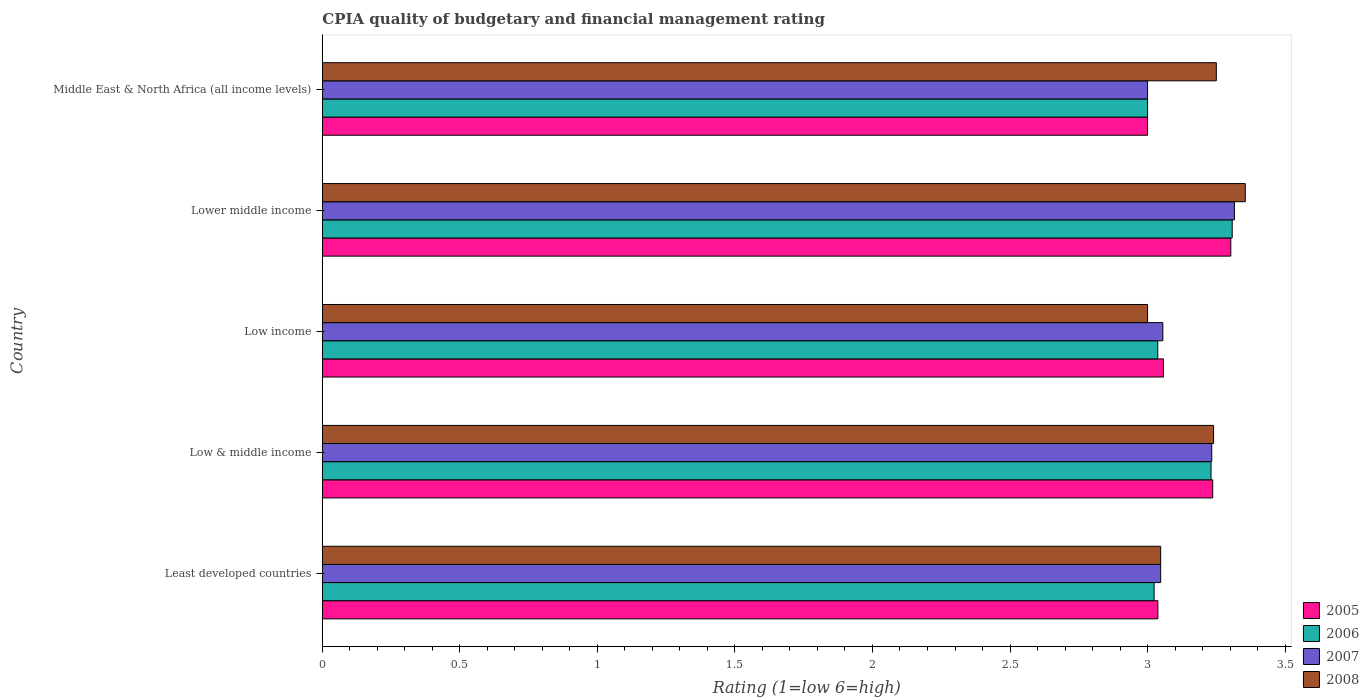How many different coloured bars are there?
Provide a succinct answer. 4. Are the number of bars per tick equal to the number of legend labels?
Make the answer very short. Yes. How many bars are there on the 3rd tick from the bottom?
Offer a terse response. 4. What is the label of the 5th group of bars from the top?
Offer a terse response. Least developed countries. In how many cases, is the number of bars for a given country not equal to the number of legend labels?
Offer a terse response. 0. What is the CPIA rating in 2006 in Low income?
Offer a very short reply. 3.04. Across all countries, what is the maximum CPIA rating in 2006?
Ensure brevity in your answer.  3.31. In which country was the CPIA rating in 2007 maximum?
Provide a succinct answer. Lower middle income. In which country was the CPIA rating in 2005 minimum?
Your answer should be compact. Middle East & North Africa (all income levels). What is the total CPIA rating in 2005 in the graph?
Ensure brevity in your answer.  15.63. What is the difference between the CPIA rating in 2005 in Low & middle income and that in Lower middle income?
Provide a succinct answer. -0.07. What is the difference between the CPIA rating in 2005 in Middle East & North Africa (all income levels) and the CPIA rating in 2007 in Low & middle income?
Give a very brief answer. -0.23. What is the average CPIA rating in 2008 per country?
Provide a short and direct response. 3.18. What is the difference between the CPIA rating in 2006 and CPIA rating in 2008 in Low income?
Make the answer very short. 0.04. What is the ratio of the CPIA rating in 2006 in Lower middle income to that in Middle East & North Africa (all income levels)?
Your response must be concise. 1.1. Is the CPIA rating in 2006 in Least developed countries less than that in Low income?
Your answer should be compact. Yes. Is the difference between the CPIA rating in 2006 in Lower middle income and Middle East & North Africa (all income levels) greater than the difference between the CPIA rating in 2008 in Lower middle income and Middle East & North Africa (all income levels)?
Your response must be concise. Yes. What is the difference between the highest and the second highest CPIA rating in 2006?
Offer a very short reply. 0.08. What is the difference between the highest and the lowest CPIA rating in 2007?
Your answer should be compact. 0.32. In how many countries, is the CPIA rating in 2007 greater than the average CPIA rating in 2007 taken over all countries?
Give a very brief answer. 2. Is it the case that in every country, the sum of the CPIA rating in 2007 and CPIA rating in 2006 is greater than the sum of CPIA rating in 2008 and CPIA rating in 2005?
Your response must be concise. No. How many bars are there?
Make the answer very short. 20. Does the graph contain any zero values?
Your response must be concise. No. Does the graph contain grids?
Your answer should be very brief. No. How many legend labels are there?
Ensure brevity in your answer.  4. How are the legend labels stacked?
Provide a succinct answer. Vertical. What is the title of the graph?
Give a very brief answer. CPIA quality of budgetary and financial management rating. Does "1990" appear as one of the legend labels in the graph?
Ensure brevity in your answer.  No. What is the Rating (1=low 6=high) in 2005 in Least developed countries?
Make the answer very short. 3.04. What is the Rating (1=low 6=high) in 2006 in Least developed countries?
Your answer should be very brief. 3.02. What is the Rating (1=low 6=high) in 2007 in Least developed countries?
Your answer should be very brief. 3.05. What is the Rating (1=low 6=high) in 2008 in Least developed countries?
Keep it short and to the point. 3.05. What is the Rating (1=low 6=high) of 2005 in Low & middle income?
Keep it short and to the point. 3.24. What is the Rating (1=low 6=high) of 2006 in Low & middle income?
Provide a short and direct response. 3.23. What is the Rating (1=low 6=high) of 2007 in Low & middle income?
Provide a short and direct response. 3.23. What is the Rating (1=low 6=high) in 2008 in Low & middle income?
Offer a very short reply. 3.24. What is the Rating (1=low 6=high) in 2005 in Low income?
Ensure brevity in your answer.  3.06. What is the Rating (1=low 6=high) in 2006 in Low income?
Provide a succinct answer. 3.04. What is the Rating (1=low 6=high) of 2007 in Low income?
Provide a succinct answer. 3.06. What is the Rating (1=low 6=high) of 2005 in Lower middle income?
Provide a short and direct response. 3.3. What is the Rating (1=low 6=high) in 2006 in Lower middle income?
Ensure brevity in your answer.  3.31. What is the Rating (1=low 6=high) in 2007 in Lower middle income?
Give a very brief answer. 3.32. What is the Rating (1=low 6=high) of 2008 in Lower middle income?
Provide a succinct answer. 3.36. What is the Rating (1=low 6=high) of 2008 in Middle East & North Africa (all income levels)?
Provide a short and direct response. 3.25. Across all countries, what is the maximum Rating (1=low 6=high) of 2005?
Make the answer very short. 3.3. Across all countries, what is the maximum Rating (1=low 6=high) of 2006?
Offer a very short reply. 3.31. Across all countries, what is the maximum Rating (1=low 6=high) of 2007?
Your response must be concise. 3.32. Across all countries, what is the maximum Rating (1=low 6=high) in 2008?
Your answer should be very brief. 3.36. Across all countries, what is the minimum Rating (1=low 6=high) of 2007?
Make the answer very short. 3. Across all countries, what is the minimum Rating (1=low 6=high) of 2008?
Your answer should be very brief. 3. What is the total Rating (1=low 6=high) of 2005 in the graph?
Provide a short and direct response. 15.63. What is the total Rating (1=low 6=high) in 2006 in the graph?
Provide a succinct answer. 15.6. What is the total Rating (1=low 6=high) in 2007 in the graph?
Your answer should be very brief. 15.65. What is the total Rating (1=low 6=high) in 2008 in the graph?
Offer a very short reply. 15.89. What is the difference between the Rating (1=low 6=high) in 2005 in Least developed countries and that in Low & middle income?
Provide a short and direct response. -0.2. What is the difference between the Rating (1=low 6=high) of 2006 in Least developed countries and that in Low & middle income?
Your answer should be compact. -0.21. What is the difference between the Rating (1=low 6=high) in 2007 in Least developed countries and that in Low & middle income?
Give a very brief answer. -0.19. What is the difference between the Rating (1=low 6=high) of 2008 in Least developed countries and that in Low & middle income?
Your answer should be compact. -0.19. What is the difference between the Rating (1=low 6=high) in 2005 in Least developed countries and that in Low income?
Ensure brevity in your answer.  -0.02. What is the difference between the Rating (1=low 6=high) of 2006 in Least developed countries and that in Low income?
Your answer should be compact. -0.01. What is the difference between the Rating (1=low 6=high) of 2007 in Least developed countries and that in Low income?
Ensure brevity in your answer.  -0.01. What is the difference between the Rating (1=low 6=high) of 2008 in Least developed countries and that in Low income?
Your answer should be very brief. 0.05. What is the difference between the Rating (1=low 6=high) of 2005 in Least developed countries and that in Lower middle income?
Your answer should be very brief. -0.27. What is the difference between the Rating (1=low 6=high) of 2006 in Least developed countries and that in Lower middle income?
Your answer should be compact. -0.28. What is the difference between the Rating (1=low 6=high) in 2007 in Least developed countries and that in Lower middle income?
Give a very brief answer. -0.27. What is the difference between the Rating (1=low 6=high) in 2008 in Least developed countries and that in Lower middle income?
Your response must be concise. -0.31. What is the difference between the Rating (1=low 6=high) of 2005 in Least developed countries and that in Middle East & North Africa (all income levels)?
Make the answer very short. 0.04. What is the difference between the Rating (1=low 6=high) in 2006 in Least developed countries and that in Middle East & North Africa (all income levels)?
Give a very brief answer. 0.02. What is the difference between the Rating (1=low 6=high) in 2007 in Least developed countries and that in Middle East & North Africa (all income levels)?
Make the answer very short. 0.05. What is the difference between the Rating (1=low 6=high) of 2008 in Least developed countries and that in Middle East & North Africa (all income levels)?
Your answer should be very brief. -0.2. What is the difference between the Rating (1=low 6=high) of 2005 in Low & middle income and that in Low income?
Give a very brief answer. 0.18. What is the difference between the Rating (1=low 6=high) in 2006 in Low & middle income and that in Low income?
Ensure brevity in your answer.  0.19. What is the difference between the Rating (1=low 6=high) in 2007 in Low & middle income and that in Low income?
Your answer should be compact. 0.18. What is the difference between the Rating (1=low 6=high) in 2008 in Low & middle income and that in Low income?
Provide a succinct answer. 0.24. What is the difference between the Rating (1=low 6=high) of 2005 in Low & middle income and that in Lower middle income?
Make the answer very short. -0.07. What is the difference between the Rating (1=low 6=high) of 2006 in Low & middle income and that in Lower middle income?
Provide a succinct answer. -0.08. What is the difference between the Rating (1=low 6=high) in 2007 in Low & middle income and that in Lower middle income?
Ensure brevity in your answer.  -0.08. What is the difference between the Rating (1=low 6=high) in 2008 in Low & middle income and that in Lower middle income?
Offer a terse response. -0.12. What is the difference between the Rating (1=low 6=high) in 2005 in Low & middle income and that in Middle East & North Africa (all income levels)?
Ensure brevity in your answer.  0.24. What is the difference between the Rating (1=low 6=high) in 2006 in Low & middle income and that in Middle East & North Africa (all income levels)?
Provide a succinct answer. 0.23. What is the difference between the Rating (1=low 6=high) of 2007 in Low & middle income and that in Middle East & North Africa (all income levels)?
Keep it short and to the point. 0.23. What is the difference between the Rating (1=low 6=high) in 2008 in Low & middle income and that in Middle East & North Africa (all income levels)?
Your answer should be very brief. -0.01. What is the difference between the Rating (1=low 6=high) of 2005 in Low income and that in Lower middle income?
Give a very brief answer. -0.24. What is the difference between the Rating (1=low 6=high) in 2006 in Low income and that in Lower middle income?
Keep it short and to the point. -0.27. What is the difference between the Rating (1=low 6=high) of 2007 in Low income and that in Lower middle income?
Make the answer very short. -0.26. What is the difference between the Rating (1=low 6=high) in 2008 in Low income and that in Lower middle income?
Your answer should be compact. -0.36. What is the difference between the Rating (1=low 6=high) in 2005 in Low income and that in Middle East & North Africa (all income levels)?
Your response must be concise. 0.06. What is the difference between the Rating (1=low 6=high) of 2006 in Low income and that in Middle East & North Africa (all income levels)?
Keep it short and to the point. 0.04. What is the difference between the Rating (1=low 6=high) in 2007 in Low income and that in Middle East & North Africa (all income levels)?
Give a very brief answer. 0.06. What is the difference between the Rating (1=low 6=high) in 2005 in Lower middle income and that in Middle East & North Africa (all income levels)?
Offer a terse response. 0.3. What is the difference between the Rating (1=low 6=high) of 2006 in Lower middle income and that in Middle East & North Africa (all income levels)?
Keep it short and to the point. 0.31. What is the difference between the Rating (1=low 6=high) in 2007 in Lower middle income and that in Middle East & North Africa (all income levels)?
Your answer should be very brief. 0.32. What is the difference between the Rating (1=low 6=high) of 2008 in Lower middle income and that in Middle East & North Africa (all income levels)?
Your answer should be compact. 0.11. What is the difference between the Rating (1=low 6=high) in 2005 in Least developed countries and the Rating (1=low 6=high) in 2006 in Low & middle income?
Provide a short and direct response. -0.19. What is the difference between the Rating (1=low 6=high) in 2005 in Least developed countries and the Rating (1=low 6=high) in 2007 in Low & middle income?
Provide a succinct answer. -0.2. What is the difference between the Rating (1=low 6=high) in 2005 in Least developed countries and the Rating (1=low 6=high) in 2008 in Low & middle income?
Provide a succinct answer. -0.2. What is the difference between the Rating (1=low 6=high) of 2006 in Least developed countries and the Rating (1=low 6=high) of 2007 in Low & middle income?
Offer a very short reply. -0.21. What is the difference between the Rating (1=low 6=high) of 2006 in Least developed countries and the Rating (1=low 6=high) of 2008 in Low & middle income?
Make the answer very short. -0.22. What is the difference between the Rating (1=low 6=high) of 2007 in Least developed countries and the Rating (1=low 6=high) of 2008 in Low & middle income?
Ensure brevity in your answer.  -0.19. What is the difference between the Rating (1=low 6=high) of 2005 in Least developed countries and the Rating (1=low 6=high) of 2006 in Low income?
Your response must be concise. 0. What is the difference between the Rating (1=low 6=high) in 2005 in Least developed countries and the Rating (1=low 6=high) in 2007 in Low income?
Offer a terse response. -0.02. What is the difference between the Rating (1=low 6=high) in 2005 in Least developed countries and the Rating (1=low 6=high) in 2008 in Low income?
Give a very brief answer. 0.04. What is the difference between the Rating (1=low 6=high) in 2006 in Least developed countries and the Rating (1=low 6=high) in 2007 in Low income?
Your answer should be very brief. -0.03. What is the difference between the Rating (1=low 6=high) in 2006 in Least developed countries and the Rating (1=low 6=high) in 2008 in Low income?
Provide a short and direct response. 0.02. What is the difference between the Rating (1=low 6=high) in 2007 in Least developed countries and the Rating (1=low 6=high) in 2008 in Low income?
Give a very brief answer. 0.05. What is the difference between the Rating (1=low 6=high) of 2005 in Least developed countries and the Rating (1=low 6=high) of 2006 in Lower middle income?
Your response must be concise. -0.27. What is the difference between the Rating (1=low 6=high) of 2005 in Least developed countries and the Rating (1=low 6=high) of 2007 in Lower middle income?
Offer a terse response. -0.28. What is the difference between the Rating (1=low 6=high) of 2005 in Least developed countries and the Rating (1=low 6=high) of 2008 in Lower middle income?
Keep it short and to the point. -0.32. What is the difference between the Rating (1=low 6=high) of 2006 in Least developed countries and the Rating (1=low 6=high) of 2007 in Lower middle income?
Give a very brief answer. -0.29. What is the difference between the Rating (1=low 6=high) in 2006 in Least developed countries and the Rating (1=low 6=high) in 2008 in Lower middle income?
Your response must be concise. -0.33. What is the difference between the Rating (1=low 6=high) of 2007 in Least developed countries and the Rating (1=low 6=high) of 2008 in Lower middle income?
Your answer should be very brief. -0.31. What is the difference between the Rating (1=low 6=high) of 2005 in Least developed countries and the Rating (1=low 6=high) of 2006 in Middle East & North Africa (all income levels)?
Keep it short and to the point. 0.04. What is the difference between the Rating (1=low 6=high) in 2005 in Least developed countries and the Rating (1=low 6=high) in 2007 in Middle East & North Africa (all income levels)?
Your response must be concise. 0.04. What is the difference between the Rating (1=low 6=high) of 2005 in Least developed countries and the Rating (1=low 6=high) of 2008 in Middle East & North Africa (all income levels)?
Your response must be concise. -0.21. What is the difference between the Rating (1=low 6=high) of 2006 in Least developed countries and the Rating (1=low 6=high) of 2007 in Middle East & North Africa (all income levels)?
Ensure brevity in your answer.  0.02. What is the difference between the Rating (1=low 6=high) of 2006 in Least developed countries and the Rating (1=low 6=high) of 2008 in Middle East & North Africa (all income levels)?
Your answer should be very brief. -0.23. What is the difference between the Rating (1=low 6=high) of 2007 in Least developed countries and the Rating (1=low 6=high) of 2008 in Middle East & North Africa (all income levels)?
Offer a terse response. -0.2. What is the difference between the Rating (1=low 6=high) of 2005 in Low & middle income and the Rating (1=low 6=high) of 2006 in Low income?
Keep it short and to the point. 0.2. What is the difference between the Rating (1=low 6=high) of 2005 in Low & middle income and the Rating (1=low 6=high) of 2007 in Low income?
Keep it short and to the point. 0.18. What is the difference between the Rating (1=low 6=high) of 2005 in Low & middle income and the Rating (1=low 6=high) of 2008 in Low income?
Provide a succinct answer. 0.24. What is the difference between the Rating (1=low 6=high) in 2006 in Low & middle income and the Rating (1=low 6=high) in 2007 in Low income?
Offer a very short reply. 0.18. What is the difference between the Rating (1=low 6=high) in 2006 in Low & middle income and the Rating (1=low 6=high) in 2008 in Low income?
Give a very brief answer. 0.23. What is the difference between the Rating (1=low 6=high) of 2007 in Low & middle income and the Rating (1=low 6=high) of 2008 in Low income?
Give a very brief answer. 0.23. What is the difference between the Rating (1=low 6=high) of 2005 in Low & middle income and the Rating (1=low 6=high) of 2006 in Lower middle income?
Your answer should be very brief. -0.07. What is the difference between the Rating (1=low 6=high) in 2005 in Low & middle income and the Rating (1=low 6=high) in 2007 in Lower middle income?
Offer a terse response. -0.08. What is the difference between the Rating (1=low 6=high) of 2005 in Low & middle income and the Rating (1=low 6=high) of 2008 in Lower middle income?
Provide a succinct answer. -0.12. What is the difference between the Rating (1=low 6=high) in 2006 in Low & middle income and the Rating (1=low 6=high) in 2007 in Lower middle income?
Your answer should be very brief. -0.09. What is the difference between the Rating (1=low 6=high) in 2006 in Low & middle income and the Rating (1=low 6=high) in 2008 in Lower middle income?
Your answer should be compact. -0.12. What is the difference between the Rating (1=low 6=high) in 2007 in Low & middle income and the Rating (1=low 6=high) in 2008 in Lower middle income?
Provide a short and direct response. -0.12. What is the difference between the Rating (1=low 6=high) in 2005 in Low & middle income and the Rating (1=low 6=high) in 2006 in Middle East & North Africa (all income levels)?
Make the answer very short. 0.24. What is the difference between the Rating (1=low 6=high) in 2005 in Low & middle income and the Rating (1=low 6=high) in 2007 in Middle East & North Africa (all income levels)?
Offer a very short reply. 0.24. What is the difference between the Rating (1=low 6=high) of 2005 in Low & middle income and the Rating (1=low 6=high) of 2008 in Middle East & North Africa (all income levels)?
Give a very brief answer. -0.01. What is the difference between the Rating (1=low 6=high) in 2006 in Low & middle income and the Rating (1=low 6=high) in 2007 in Middle East & North Africa (all income levels)?
Give a very brief answer. 0.23. What is the difference between the Rating (1=low 6=high) in 2006 in Low & middle income and the Rating (1=low 6=high) in 2008 in Middle East & North Africa (all income levels)?
Keep it short and to the point. -0.02. What is the difference between the Rating (1=low 6=high) of 2007 in Low & middle income and the Rating (1=low 6=high) of 2008 in Middle East & North Africa (all income levels)?
Your answer should be compact. -0.02. What is the difference between the Rating (1=low 6=high) in 2005 in Low income and the Rating (1=low 6=high) in 2006 in Lower middle income?
Provide a succinct answer. -0.25. What is the difference between the Rating (1=low 6=high) in 2005 in Low income and the Rating (1=low 6=high) in 2007 in Lower middle income?
Offer a very short reply. -0.26. What is the difference between the Rating (1=low 6=high) of 2005 in Low income and the Rating (1=low 6=high) of 2008 in Lower middle income?
Your answer should be compact. -0.3. What is the difference between the Rating (1=low 6=high) of 2006 in Low income and the Rating (1=low 6=high) of 2007 in Lower middle income?
Offer a terse response. -0.28. What is the difference between the Rating (1=low 6=high) of 2006 in Low income and the Rating (1=low 6=high) of 2008 in Lower middle income?
Provide a short and direct response. -0.32. What is the difference between the Rating (1=low 6=high) in 2007 in Low income and the Rating (1=low 6=high) in 2008 in Lower middle income?
Provide a short and direct response. -0.3. What is the difference between the Rating (1=low 6=high) in 2005 in Low income and the Rating (1=low 6=high) in 2006 in Middle East & North Africa (all income levels)?
Offer a very short reply. 0.06. What is the difference between the Rating (1=low 6=high) of 2005 in Low income and the Rating (1=low 6=high) of 2007 in Middle East & North Africa (all income levels)?
Your answer should be very brief. 0.06. What is the difference between the Rating (1=low 6=high) in 2005 in Low income and the Rating (1=low 6=high) in 2008 in Middle East & North Africa (all income levels)?
Give a very brief answer. -0.19. What is the difference between the Rating (1=low 6=high) in 2006 in Low income and the Rating (1=low 6=high) in 2007 in Middle East & North Africa (all income levels)?
Your answer should be very brief. 0.04. What is the difference between the Rating (1=low 6=high) of 2006 in Low income and the Rating (1=low 6=high) of 2008 in Middle East & North Africa (all income levels)?
Your answer should be very brief. -0.21. What is the difference between the Rating (1=low 6=high) in 2007 in Low income and the Rating (1=low 6=high) in 2008 in Middle East & North Africa (all income levels)?
Ensure brevity in your answer.  -0.19. What is the difference between the Rating (1=low 6=high) of 2005 in Lower middle income and the Rating (1=low 6=high) of 2006 in Middle East & North Africa (all income levels)?
Offer a very short reply. 0.3. What is the difference between the Rating (1=low 6=high) in 2005 in Lower middle income and the Rating (1=low 6=high) in 2007 in Middle East & North Africa (all income levels)?
Give a very brief answer. 0.3. What is the difference between the Rating (1=low 6=high) in 2005 in Lower middle income and the Rating (1=low 6=high) in 2008 in Middle East & North Africa (all income levels)?
Offer a very short reply. 0.05. What is the difference between the Rating (1=low 6=high) of 2006 in Lower middle income and the Rating (1=low 6=high) of 2007 in Middle East & North Africa (all income levels)?
Provide a short and direct response. 0.31. What is the difference between the Rating (1=low 6=high) in 2006 in Lower middle income and the Rating (1=low 6=high) in 2008 in Middle East & North Africa (all income levels)?
Your answer should be compact. 0.06. What is the difference between the Rating (1=low 6=high) in 2007 in Lower middle income and the Rating (1=low 6=high) in 2008 in Middle East & North Africa (all income levels)?
Keep it short and to the point. 0.07. What is the average Rating (1=low 6=high) in 2005 per country?
Offer a terse response. 3.13. What is the average Rating (1=low 6=high) in 2006 per country?
Make the answer very short. 3.12. What is the average Rating (1=low 6=high) of 2007 per country?
Ensure brevity in your answer.  3.13. What is the average Rating (1=low 6=high) in 2008 per country?
Offer a terse response. 3.18. What is the difference between the Rating (1=low 6=high) in 2005 and Rating (1=low 6=high) in 2006 in Least developed countries?
Make the answer very short. 0.01. What is the difference between the Rating (1=low 6=high) in 2005 and Rating (1=low 6=high) in 2007 in Least developed countries?
Your answer should be compact. -0.01. What is the difference between the Rating (1=low 6=high) in 2005 and Rating (1=low 6=high) in 2008 in Least developed countries?
Your answer should be very brief. -0.01. What is the difference between the Rating (1=low 6=high) of 2006 and Rating (1=low 6=high) of 2007 in Least developed countries?
Your answer should be very brief. -0.02. What is the difference between the Rating (1=low 6=high) of 2006 and Rating (1=low 6=high) of 2008 in Least developed countries?
Give a very brief answer. -0.02. What is the difference between the Rating (1=low 6=high) of 2007 and Rating (1=low 6=high) of 2008 in Least developed countries?
Make the answer very short. 0. What is the difference between the Rating (1=low 6=high) in 2005 and Rating (1=low 6=high) in 2006 in Low & middle income?
Offer a terse response. 0.01. What is the difference between the Rating (1=low 6=high) in 2005 and Rating (1=low 6=high) in 2007 in Low & middle income?
Your answer should be very brief. 0. What is the difference between the Rating (1=low 6=high) in 2005 and Rating (1=low 6=high) in 2008 in Low & middle income?
Your answer should be compact. -0. What is the difference between the Rating (1=low 6=high) of 2006 and Rating (1=low 6=high) of 2007 in Low & middle income?
Your response must be concise. -0. What is the difference between the Rating (1=low 6=high) in 2006 and Rating (1=low 6=high) in 2008 in Low & middle income?
Your response must be concise. -0.01. What is the difference between the Rating (1=low 6=high) of 2007 and Rating (1=low 6=high) of 2008 in Low & middle income?
Provide a short and direct response. -0.01. What is the difference between the Rating (1=low 6=high) of 2005 and Rating (1=low 6=high) of 2006 in Low income?
Give a very brief answer. 0.02. What is the difference between the Rating (1=low 6=high) in 2005 and Rating (1=low 6=high) in 2007 in Low income?
Your response must be concise. 0. What is the difference between the Rating (1=low 6=high) in 2005 and Rating (1=low 6=high) in 2008 in Low income?
Ensure brevity in your answer.  0.06. What is the difference between the Rating (1=low 6=high) in 2006 and Rating (1=low 6=high) in 2007 in Low income?
Give a very brief answer. -0.02. What is the difference between the Rating (1=low 6=high) of 2006 and Rating (1=low 6=high) of 2008 in Low income?
Keep it short and to the point. 0.04. What is the difference between the Rating (1=low 6=high) in 2007 and Rating (1=low 6=high) in 2008 in Low income?
Ensure brevity in your answer.  0.06. What is the difference between the Rating (1=low 6=high) of 2005 and Rating (1=low 6=high) of 2006 in Lower middle income?
Keep it short and to the point. -0.01. What is the difference between the Rating (1=low 6=high) of 2005 and Rating (1=low 6=high) of 2007 in Lower middle income?
Offer a terse response. -0.01. What is the difference between the Rating (1=low 6=high) of 2005 and Rating (1=low 6=high) of 2008 in Lower middle income?
Keep it short and to the point. -0.05. What is the difference between the Rating (1=low 6=high) in 2006 and Rating (1=low 6=high) in 2007 in Lower middle income?
Your answer should be compact. -0.01. What is the difference between the Rating (1=low 6=high) of 2006 and Rating (1=low 6=high) of 2008 in Lower middle income?
Keep it short and to the point. -0.05. What is the difference between the Rating (1=low 6=high) in 2007 and Rating (1=low 6=high) in 2008 in Lower middle income?
Your response must be concise. -0.04. What is the difference between the Rating (1=low 6=high) of 2005 and Rating (1=low 6=high) of 2007 in Middle East & North Africa (all income levels)?
Keep it short and to the point. 0. What is the difference between the Rating (1=low 6=high) of 2005 and Rating (1=low 6=high) of 2008 in Middle East & North Africa (all income levels)?
Ensure brevity in your answer.  -0.25. What is the ratio of the Rating (1=low 6=high) in 2005 in Least developed countries to that in Low & middle income?
Keep it short and to the point. 0.94. What is the ratio of the Rating (1=low 6=high) in 2006 in Least developed countries to that in Low & middle income?
Offer a terse response. 0.94. What is the ratio of the Rating (1=low 6=high) in 2007 in Least developed countries to that in Low & middle income?
Your response must be concise. 0.94. What is the ratio of the Rating (1=low 6=high) of 2008 in Least developed countries to that in Low & middle income?
Offer a terse response. 0.94. What is the ratio of the Rating (1=low 6=high) in 2005 in Least developed countries to that in Low income?
Your answer should be compact. 0.99. What is the ratio of the Rating (1=low 6=high) in 2008 in Least developed countries to that in Low income?
Give a very brief answer. 1.02. What is the ratio of the Rating (1=low 6=high) of 2005 in Least developed countries to that in Lower middle income?
Make the answer very short. 0.92. What is the ratio of the Rating (1=low 6=high) of 2006 in Least developed countries to that in Lower middle income?
Offer a very short reply. 0.91. What is the ratio of the Rating (1=low 6=high) of 2007 in Least developed countries to that in Lower middle income?
Offer a terse response. 0.92. What is the ratio of the Rating (1=low 6=high) in 2008 in Least developed countries to that in Lower middle income?
Provide a short and direct response. 0.91. What is the ratio of the Rating (1=low 6=high) of 2005 in Least developed countries to that in Middle East & North Africa (all income levels)?
Your response must be concise. 1.01. What is the ratio of the Rating (1=low 6=high) of 2006 in Least developed countries to that in Middle East & North Africa (all income levels)?
Give a very brief answer. 1.01. What is the ratio of the Rating (1=low 6=high) in 2007 in Least developed countries to that in Middle East & North Africa (all income levels)?
Offer a terse response. 1.02. What is the ratio of the Rating (1=low 6=high) in 2008 in Least developed countries to that in Middle East & North Africa (all income levels)?
Provide a succinct answer. 0.94. What is the ratio of the Rating (1=low 6=high) in 2005 in Low & middle income to that in Low income?
Your response must be concise. 1.06. What is the ratio of the Rating (1=low 6=high) of 2006 in Low & middle income to that in Low income?
Keep it short and to the point. 1.06. What is the ratio of the Rating (1=low 6=high) in 2007 in Low & middle income to that in Low income?
Offer a terse response. 1.06. What is the ratio of the Rating (1=low 6=high) in 2008 in Low & middle income to that in Low income?
Make the answer very short. 1.08. What is the ratio of the Rating (1=low 6=high) of 2005 in Low & middle income to that in Lower middle income?
Offer a terse response. 0.98. What is the ratio of the Rating (1=low 6=high) of 2006 in Low & middle income to that in Lower middle income?
Give a very brief answer. 0.98. What is the ratio of the Rating (1=low 6=high) in 2007 in Low & middle income to that in Lower middle income?
Your response must be concise. 0.98. What is the ratio of the Rating (1=low 6=high) of 2008 in Low & middle income to that in Lower middle income?
Offer a terse response. 0.97. What is the ratio of the Rating (1=low 6=high) in 2005 in Low & middle income to that in Middle East & North Africa (all income levels)?
Provide a short and direct response. 1.08. What is the ratio of the Rating (1=low 6=high) in 2007 in Low & middle income to that in Middle East & North Africa (all income levels)?
Your answer should be very brief. 1.08. What is the ratio of the Rating (1=low 6=high) of 2008 in Low & middle income to that in Middle East & North Africa (all income levels)?
Keep it short and to the point. 1. What is the ratio of the Rating (1=low 6=high) of 2005 in Low income to that in Lower middle income?
Offer a terse response. 0.93. What is the ratio of the Rating (1=low 6=high) of 2006 in Low income to that in Lower middle income?
Offer a terse response. 0.92. What is the ratio of the Rating (1=low 6=high) of 2007 in Low income to that in Lower middle income?
Offer a terse response. 0.92. What is the ratio of the Rating (1=low 6=high) of 2008 in Low income to that in Lower middle income?
Make the answer very short. 0.89. What is the ratio of the Rating (1=low 6=high) of 2005 in Low income to that in Middle East & North Africa (all income levels)?
Ensure brevity in your answer.  1.02. What is the ratio of the Rating (1=low 6=high) of 2006 in Low income to that in Middle East & North Africa (all income levels)?
Your answer should be compact. 1.01. What is the ratio of the Rating (1=low 6=high) of 2007 in Low income to that in Middle East & North Africa (all income levels)?
Your answer should be compact. 1.02. What is the ratio of the Rating (1=low 6=high) of 2008 in Low income to that in Middle East & North Africa (all income levels)?
Provide a short and direct response. 0.92. What is the ratio of the Rating (1=low 6=high) of 2005 in Lower middle income to that in Middle East & North Africa (all income levels)?
Provide a short and direct response. 1.1. What is the ratio of the Rating (1=low 6=high) in 2006 in Lower middle income to that in Middle East & North Africa (all income levels)?
Offer a terse response. 1.1. What is the ratio of the Rating (1=low 6=high) in 2007 in Lower middle income to that in Middle East & North Africa (all income levels)?
Give a very brief answer. 1.11. What is the ratio of the Rating (1=low 6=high) of 2008 in Lower middle income to that in Middle East & North Africa (all income levels)?
Ensure brevity in your answer.  1.03. What is the difference between the highest and the second highest Rating (1=low 6=high) of 2005?
Provide a short and direct response. 0.07. What is the difference between the highest and the second highest Rating (1=low 6=high) in 2006?
Your answer should be very brief. 0.08. What is the difference between the highest and the second highest Rating (1=low 6=high) of 2007?
Ensure brevity in your answer.  0.08. What is the difference between the highest and the second highest Rating (1=low 6=high) of 2008?
Give a very brief answer. 0.11. What is the difference between the highest and the lowest Rating (1=low 6=high) of 2005?
Provide a short and direct response. 0.3. What is the difference between the highest and the lowest Rating (1=low 6=high) in 2006?
Keep it short and to the point. 0.31. What is the difference between the highest and the lowest Rating (1=low 6=high) of 2007?
Provide a succinct answer. 0.32. What is the difference between the highest and the lowest Rating (1=low 6=high) of 2008?
Provide a short and direct response. 0.36. 